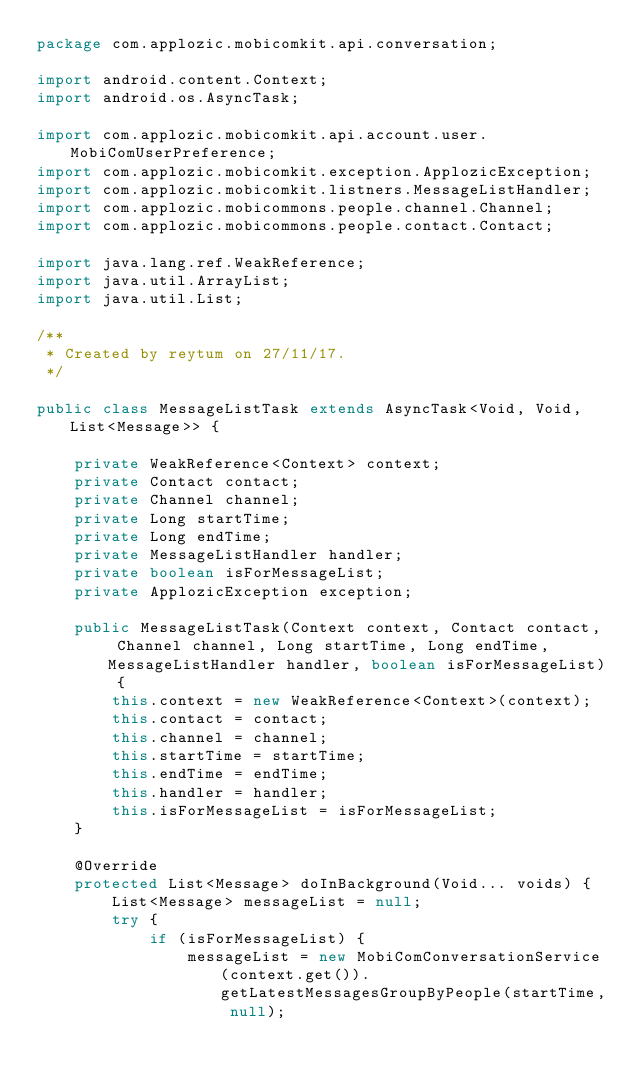Convert code to text. <code><loc_0><loc_0><loc_500><loc_500><_Java_>package com.applozic.mobicomkit.api.conversation;

import android.content.Context;
import android.os.AsyncTask;

import com.applozic.mobicomkit.api.account.user.MobiComUserPreference;
import com.applozic.mobicomkit.exception.ApplozicException;
import com.applozic.mobicomkit.listners.MessageListHandler;
import com.applozic.mobicommons.people.channel.Channel;
import com.applozic.mobicommons.people.contact.Contact;

import java.lang.ref.WeakReference;
import java.util.ArrayList;
import java.util.List;

/**
 * Created by reytum on 27/11/17.
 */

public class MessageListTask extends AsyncTask<Void, Void, List<Message>> {

    private WeakReference<Context> context;
    private Contact contact;
    private Channel channel;
    private Long startTime;
    private Long endTime;
    private MessageListHandler handler;
    private boolean isForMessageList;
    private ApplozicException exception;

    public MessageListTask(Context context, Contact contact, Channel channel, Long startTime, Long endTime, MessageListHandler handler, boolean isForMessageList) {
        this.context = new WeakReference<Context>(context);
        this.contact = contact;
        this.channel = channel;
        this.startTime = startTime;
        this.endTime = endTime;
        this.handler = handler;
        this.isForMessageList = isForMessageList;
    }

    @Override
    protected List<Message> doInBackground(Void... voids) {
        List<Message> messageList = null;
        try {
            if (isForMessageList) {
                messageList = new MobiComConversationService(context.get()).getLatestMessagesGroupByPeople(startTime, null);</code> 